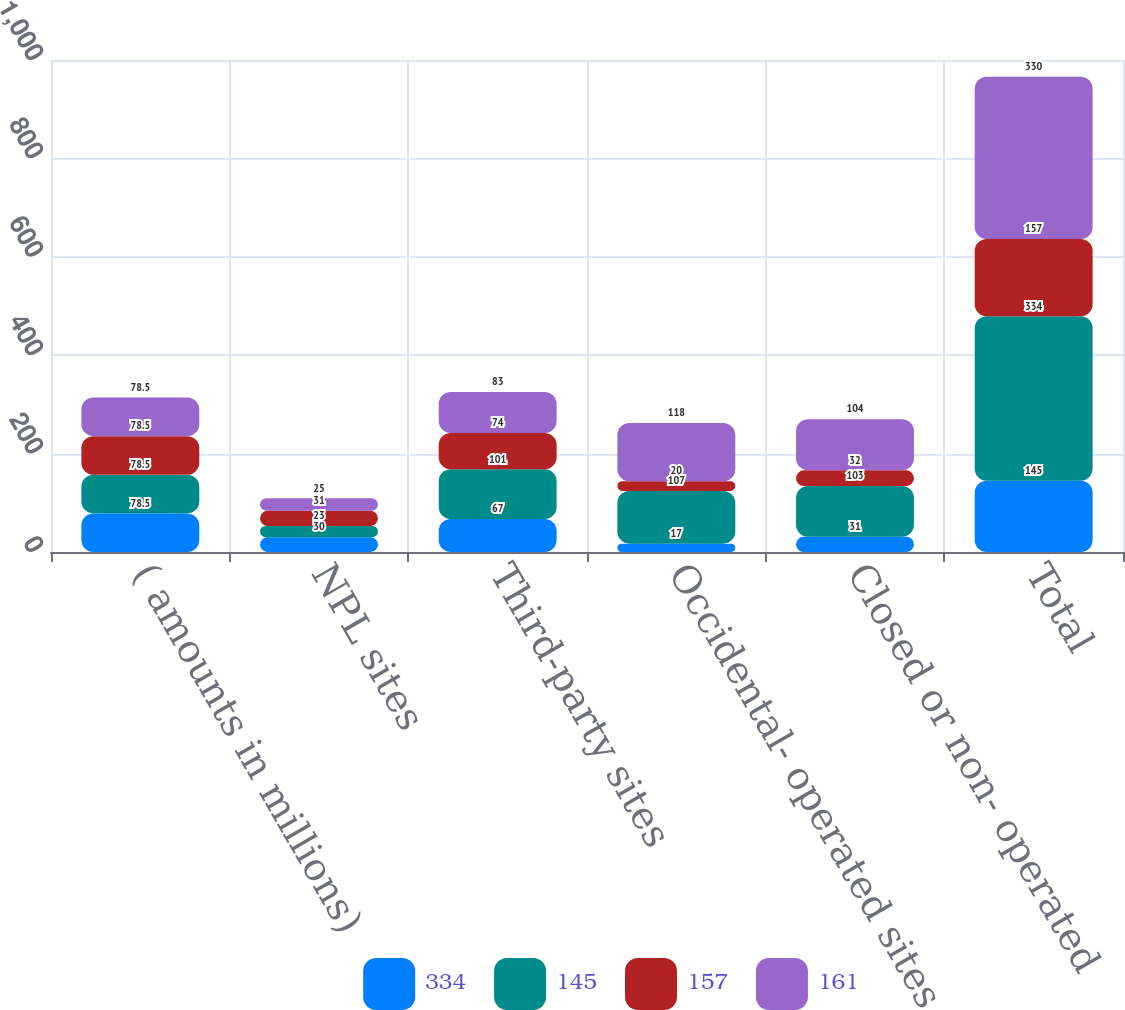Convert chart to OTSL. <chart><loc_0><loc_0><loc_500><loc_500><stacked_bar_chart><ecel><fcel>( amounts in millions)<fcel>NPL sites<fcel>Third-party sites<fcel>Occidental- operated sites<fcel>Closed or non- operated<fcel>Total<nl><fcel>334<fcel>78.5<fcel>30<fcel>67<fcel>17<fcel>31<fcel>145<nl><fcel>145<fcel>78.5<fcel>23<fcel>101<fcel>107<fcel>103<fcel>334<nl><fcel>157<fcel>78.5<fcel>31<fcel>74<fcel>20<fcel>32<fcel>157<nl><fcel>161<fcel>78.5<fcel>25<fcel>83<fcel>118<fcel>104<fcel>330<nl></chart> 